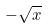Convert formula to latex. <formula><loc_0><loc_0><loc_500><loc_500>- \sqrt { x }</formula> 